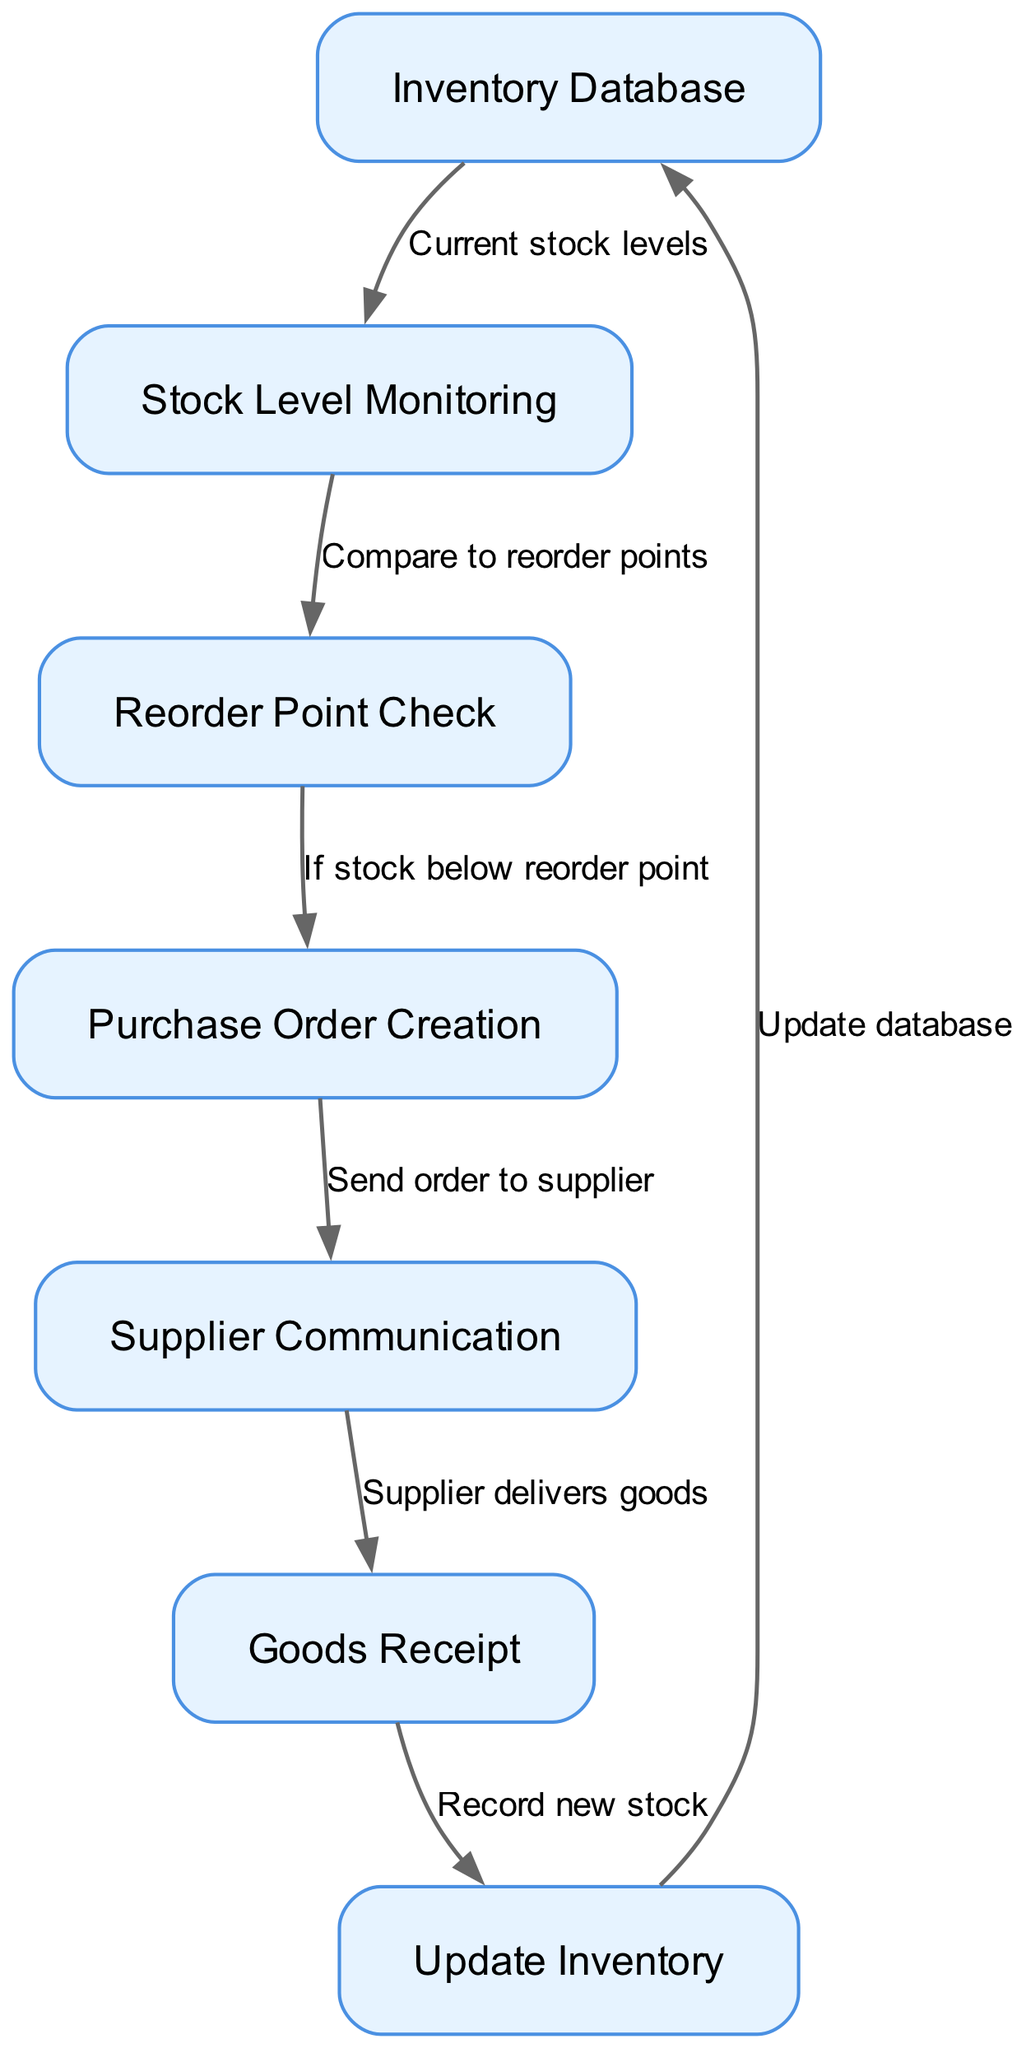What's the total number of nodes in the diagram? The diagram has a defined structure that includes seven nodes which represent different stages in the inventory management process. Counting these nodes will give the total.
Answer: 7 What is the first node in the process flow? The flow starts at the "Inventory Database," which is the first node. This can be determined by examining the edges in the diagram that lead away from initial nodes.
Answer: Inventory Database What label is assigned to the edge between "Reorder Point Check" and "Purchase Order Creation"? The edge connecting these two nodes is labeled "If stock below reorder point." This label indicates the condition under which the Purchase Order Creation process is initiated.
Answer: If stock below reorder point Which node follows "Supplier Communication" in the flow? After "Supplier Communication," the next node in the flow is "Goods Receipt," which is directly connected through an edge signifying that the goods are delivered by the supplier.
Answer: Goods Receipt How many edges are in the diagram? The diagram consists of six edges, each representing the connections between the various processes in the inventory management system. By counting the lines connecting the nodes, we establish this number.
Answer: 6 What happens after the "Goods Receipt" node? After the "Goods Receipt" node, the next step is to "Update Inventory." This indicates that upon receiving goods, the inventory levels need to be adjusted accordingly.
Answer: Update Inventory What does the edge labeled "Supplier delivers goods" indicate? This edge specifies the action that occurs following "Supplier Communication," denoting that the supplier actually delivers the ordered goods as part of the supply chain process.
Answer: Supplier delivers goods What is the connection between "Update Inventory" and "Inventory Database"? The connection between these two nodes indicates that after inventory is updated, these new levels must be recorded back into the "Inventory Database," ensuring that the database reflects accurate stock levels.
Answer: Update database What is the purpose of the "Reorder Point Check" node? The "Reorder Point Check" node serves to evaluate whether the current stock levels fall below a predefined threshold, which triggers the subsequent ordering actions to replenish inventory.
Answer: Compare to reorder points 